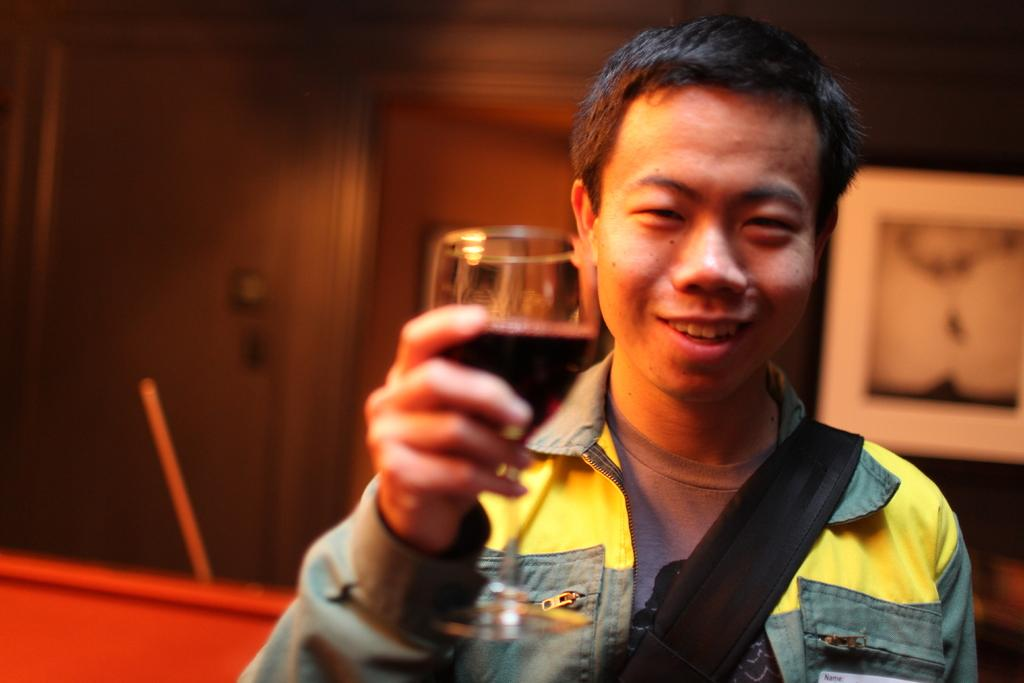What is the person in the image doing? The person is holding a wine glass. What is the person wearing in the image? The person is wearing a yellow jacket. How is the person feeling in the image? The person is smiling, which suggests they are happy or enjoying themselves. What can be seen in the background of the image? There is a wall in the background of the image. What is on the wall in the image? There is a painting on the wall. Can you see the ocean in the image? No, there is no ocean visible in the image. Is the person wearing a crown in the image? No, the person is wearing a yellow jacket, not a crown. 